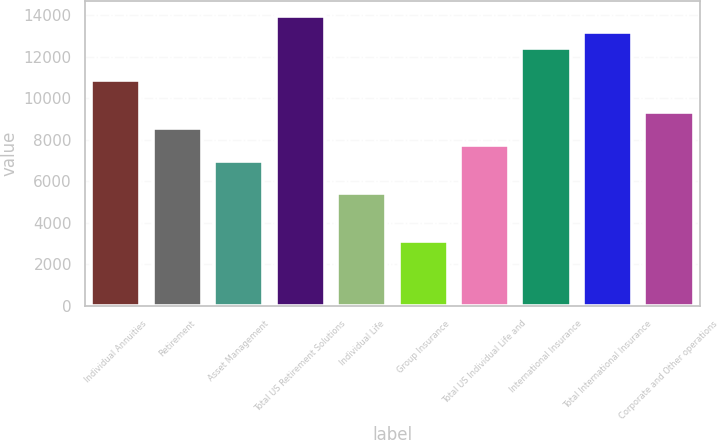Convert chart to OTSL. <chart><loc_0><loc_0><loc_500><loc_500><bar_chart><fcel>Individual Annuities<fcel>Retirement<fcel>Asset Management<fcel>Total US Retirement Solutions<fcel>Individual Life<fcel>Group Insurance<fcel>Total US Individual Life and<fcel>International Insurance<fcel>Total International Insurance<fcel>Corporate and Other operations<nl><fcel>10875<fcel>8545.51<fcel>6992.55<fcel>13980.9<fcel>5439.57<fcel>3110.1<fcel>7769.03<fcel>12428<fcel>13204.4<fcel>9322<nl></chart> 